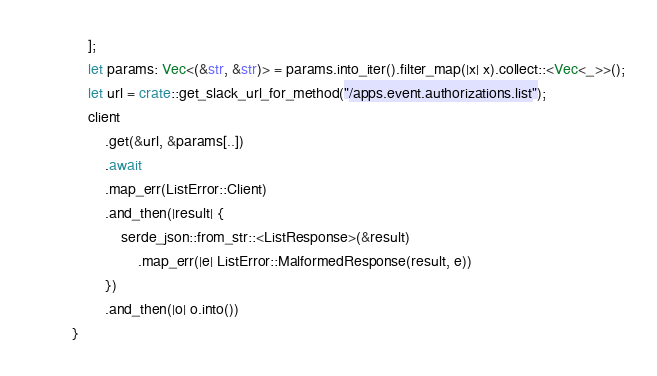Convert code to text. <code><loc_0><loc_0><loc_500><loc_500><_Rust_>    ];
    let params: Vec<(&str, &str)> = params.into_iter().filter_map(|x| x).collect::<Vec<_>>();
    let url = crate::get_slack_url_for_method("/apps.event.authorizations.list");
    client
        .get(&url, &params[..])
        .await
        .map_err(ListError::Client)
        .and_then(|result| {
            serde_json::from_str::<ListResponse>(&result)
                .map_err(|e| ListError::MalformedResponse(result, e))
        })
        .and_then(|o| o.into())
}
</code> 